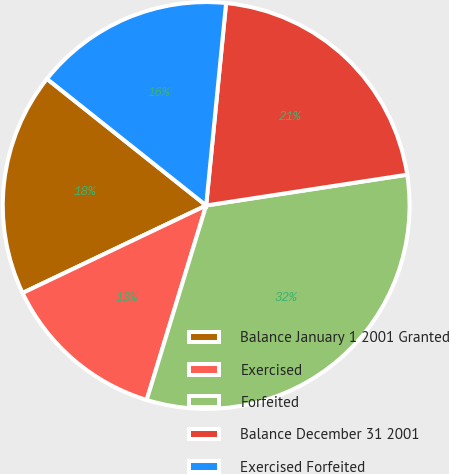Convert chart. <chart><loc_0><loc_0><loc_500><loc_500><pie_chart><fcel>Balance January 1 2001 Granted<fcel>Exercised<fcel>Forfeited<fcel>Balance December 31 2001<fcel>Exercised Forfeited<nl><fcel>17.77%<fcel>13.2%<fcel>32.14%<fcel>21.02%<fcel>15.87%<nl></chart> 